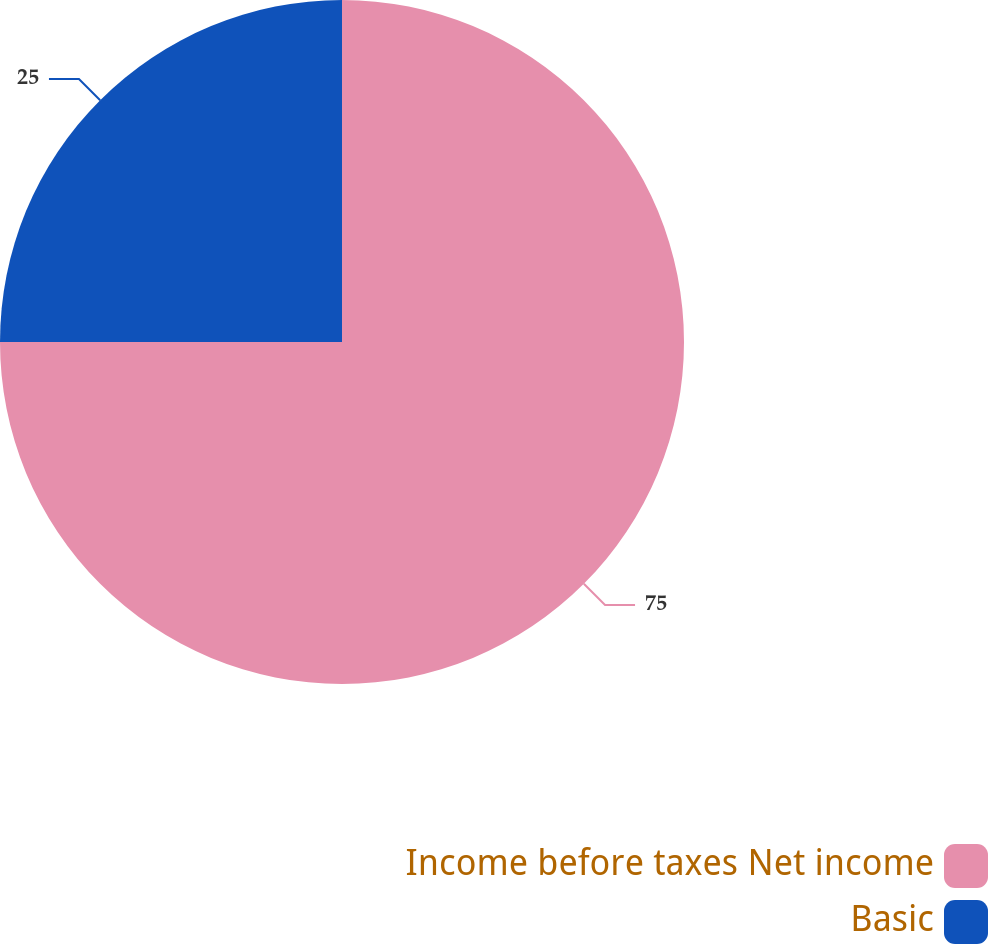Convert chart to OTSL. <chart><loc_0><loc_0><loc_500><loc_500><pie_chart><fcel>Income before taxes Net income<fcel>Basic<nl><fcel>75.0%<fcel>25.0%<nl></chart> 